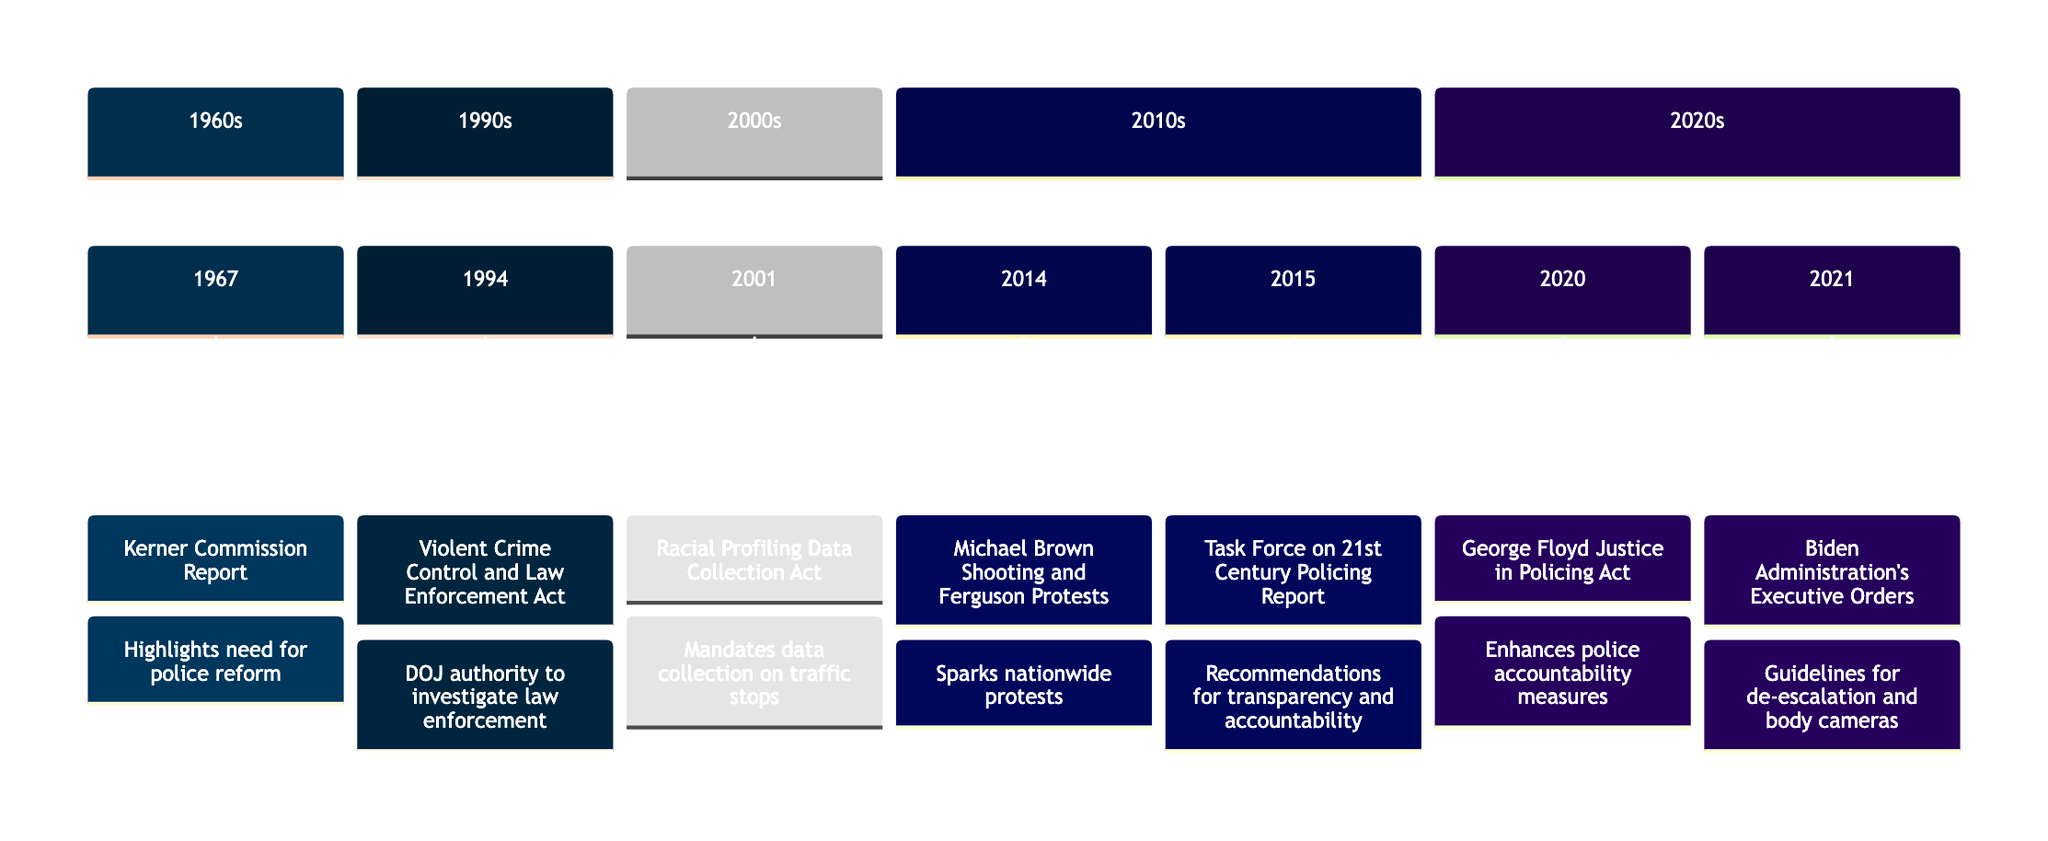What year did the Kerner Commission Report take place? The diagram specifies that the Kerner Commission Report occurred in the year 1967. This information is clearly indicated under the '1960s' section.
Answer: 1967 What event was associated with the year 2014? Looking at the timeline, the event associated with the year 2014 is the "Michael Brown Shooting and Ferguson Protests." This is straightforwardly listed under the '2010s' section.
Answer: Michael Brown Shooting and Ferguson Protests How many significant events are listed in the 2020s section? The timeline includes two significant events in the 2020s section: the "George Floyd Justice in Policing Act" (2020) and the "Biden Administration's Executive Orders" (2021). Counting these, we find two events.
Answer: 2 Which legislation was signed by President Bill Clinton? The "Violent Crime Control and Law Enforcement Act" is indicated on the timeline as the legislation signed by President Bill Clinton in 1994. This detail is specifically noted alongside the event.
Answer: Violent Crime Control and Law Enforcement Act Which bill is linked to Rep. John Conyers? The "Racial Profiling Data Collection Act," introduced by Rep. John Conyers in 2001, is highlighted in the timeline. This association can be found clearly under the 2000s section.
Answer: Racial Profiling Data Collection Act What was the main recommendation from the Task Force on 21st Century Policing Report? The Task Force's report emphasized multiple recommendations aimed at increasing transparency, community relations, and officer accountability for misconduct, as described in the timeline for 2015.
Answer: Recommendations for increasing transparency and accountability What event occurred right before the establishment of the Task Force on 21st Century Policing? The timeline indicates that the "Michael Brown Shooting and Ferguson Protests" occurred in 2014, right before the "Task Force on 21st Century Policing Report" in 2015, showing a direct cause-effect relationship in terms of events leading to the task force’s creation.
Answer: Michael Brown Shooting and Ferguson Protests What guidelines did the Biden Administration's executive orders target? The diagram specifies that the executive orders targeted guidelines for the de-escalation of force and incentivized the use of body-worn cameras, reflecting comprehensive approaches to police reform as noted in the year 2021.
Answer: Guidelines for de-escalation and body cameras Which event directly follows the George Floyd Justice in Policing Act in the timeline? The "Biden Administration's Executive Orders" occurred in 2021, which directly follows the "George Floyd Justice in Policing Act" from 2020 in the timeline’s 2020s section.
Answer: Biden Administration's Executive Orders 